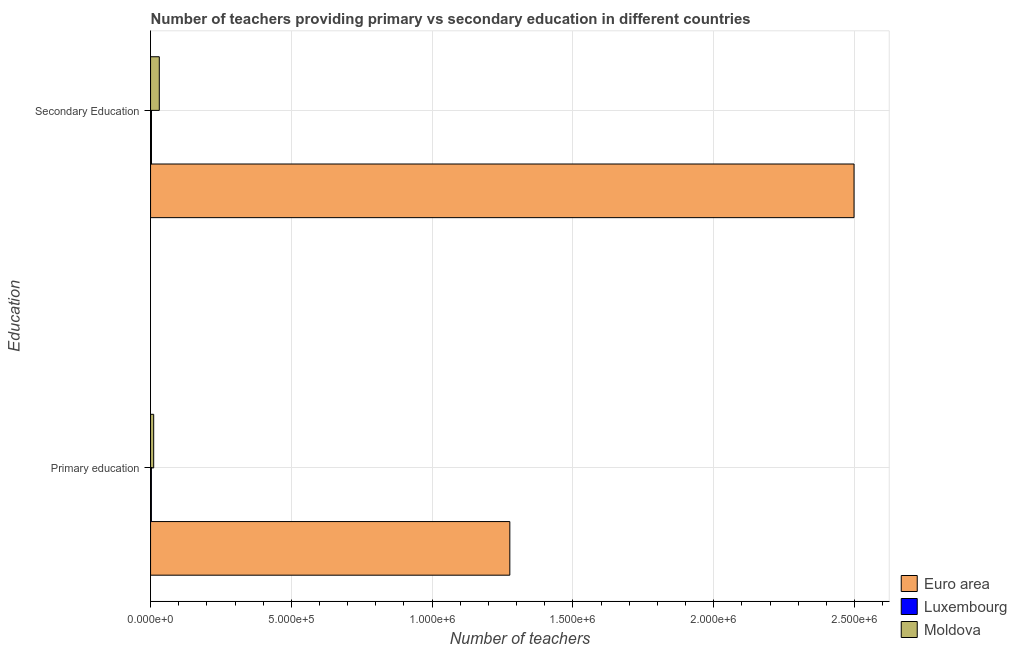How many different coloured bars are there?
Your answer should be compact. 3. How many groups of bars are there?
Provide a short and direct response. 2. Are the number of bars on each tick of the Y-axis equal?
Make the answer very short. Yes. How many bars are there on the 2nd tick from the top?
Ensure brevity in your answer.  3. How many bars are there on the 1st tick from the bottom?
Keep it short and to the point. 3. What is the label of the 1st group of bars from the top?
Give a very brief answer. Secondary Education. What is the number of secondary teachers in Moldova?
Provide a short and direct response. 3.10e+04. Across all countries, what is the maximum number of secondary teachers?
Provide a short and direct response. 2.50e+06. Across all countries, what is the minimum number of primary teachers?
Give a very brief answer. 2966. In which country was the number of secondary teachers minimum?
Ensure brevity in your answer.  Luxembourg. What is the total number of secondary teachers in the graph?
Offer a terse response. 2.53e+06. What is the difference between the number of secondary teachers in Moldova and that in Luxembourg?
Ensure brevity in your answer.  2.77e+04. What is the difference between the number of secondary teachers in Luxembourg and the number of primary teachers in Euro area?
Offer a terse response. -1.27e+06. What is the average number of primary teachers per country?
Your response must be concise. 4.30e+05. What is the difference between the number of primary teachers and number of secondary teachers in Moldova?
Provide a succinct answer. -1.99e+04. What is the ratio of the number of primary teachers in Moldova to that in Luxembourg?
Keep it short and to the point. 3.74. In how many countries, is the number of primary teachers greater than the average number of primary teachers taken over all countries?
Your response must be concise. 1. What does the 1st bar from the top in Primary education represents?
Offer a terse response. Moldova. What does the 3rd bar from the bottom in Secondary Education represents?
Your answer should be compact. Moldova. How many bars are there?
Your response must be concise. 6. What is the difference between two consecutive major ticks on the X-axis?
Provide a succinct answer. 5.00e+05. Does the graph contain any zero values?
Your response must be concise. No. Where does the legend appear in the graph?
Offer a terse response. Bottom right. What is the title of the graph?
Your response must be concise. Number of teachers providing primary vs secondary education in different countries. Does "Mali" appear as one of the legend labels in the graph?
Provide a short and direct response. No. What is the label or title of the X-axis?
Give a very brief answer. Number of teachers. What is the label or title of the Y-axis?
Ensure brevity in your answer.  Education. What is the Number of teachers in Euro area in Primary education?
Provide a succinct answer. 1.28e+06. What is the Number of teachers of Luxembourg in Primary education?
Offer a very short reply. 2966. What is the Number of teachers in Moldova in Primary education?
Provide a succinct answer. 1.11e+04. What is the Number of teachers in Euro area in Secondary Education?
Offer a very short reply. 2.50e+06. What is the Number of teachers in Luxembourg in Secondary Education?
Your response must be concise. 3279. What is the Number of teachers of Moldova in Secondary Education?
Provide a succinct answer. 3.10e+04. Across all Education, what is the maximum Number of teachers of Euro area?
Offer a terse response. 2.50e+06. Across all Education, what is the maximum Number of teachers in Luxembourg?
Ensure brevity in your answer.  3279. Across all Education, what is the maximum Number of teachers in Moldova?
Your answer should be very brief. 3.10e+04. Across all Education, what is the minimum Number of teachers of Euro area?
Give a very brief answer. 1.28e+06. Across all Education, what is the minimum Number of teachers in Luxembourg?
Provide a succinct answer. 2966. Across all Education, what is the minimum Number of teachers of Moldova?
Offer a terse response. 1.11e+04. What is the total Number of teachers in Euro area in the graph?
Your answer should be very brief. 3.77e+06. What is the total Number of teachers in Luxembourg in the graph?
Your answer should be very brief. 6245. What is the total Number of teachers of Moldova in the graph?
Your answer should be very brief. 4.21e+04. What is the difference between the Number of teachers in Euro area in Primary education and that in Secondary Education?
Your answer should be very brief. -1.22e+06. What is the difference between the Number of teachers of Luxembourg in Primary education and that in Secondary Education?
Provide a succinct answer. -313. What is the difference between the Number of teachers in Moldova in Primary education and that in Secondary Education?
Offer a terse response. -1.99e+04. What is the difference between the Number of teachers of Euro area in Primary education and the Number of teachers of Luxembourg in Secondary Education?
Your answer should be very brief. 1.27e+06. What is the difference between the Number of teachers of Euro area in Primary education and the Number of teachers of Moldova in Secondary Education?
Offer a very short reply. 1.24e+06. What is the difference between the Number of teachers of Luxembourg in Primary education and the Number of teachers of Moldova in Secondary Education?
Ensure brevity in your answer.  -2.80e+04. What is the average Number of teachers in Euro area per Education?
Provide a short and direct response. 1.89e+06. What is the average Number of teachers in Luxembourg per Education?
Provide a succinct answer. 3122.5. What is the average Number of teachers in Moldova per Education?
Keep it short and to the point. 2.10e+04. What is the difference between the Number of teachers of Euro area and Number of teachers of Luxembourg in Primary education?
Provide a short and direct response. 1.27e+06. What is the difference between the Number of teachers of Euro area and Number of teachers of Moldova in Primary education?
Provide a short and direct response. 1.26e+06. What is the difference between the Number of teachers in Luxembourg and Number of teachers in Moldova in Primary education?
Your answer should be very brief. -8121. What is the difference between the Number of teachers of Euro area and Number of teachers of Luxembourg in Secondary Education?
Your response must be concise. 2.50e+06. What is the difference between the Number of teachers of Euro area and Number of teachers of Moldova in Secondary Education?
Your answer should be compact. 2.47e+06. What is the difference between the Number of teachers of Luxembourg and Number of teachers of Moldova in Secondary Education?
Your response must be concise. -2.77e+04. What is the ratio of the Number of teachers in Euro area in Primary education to that in Secondary Education?
Provide a short and direct response. 0.51. What is the ratio of the Number of teachers of Luxembourg in Primary education to that in Secondary Education?
Offer a very short reply. 0.9. What is the ratio of the Number of teachers of Moldova in Primary education to that in Secondary Education?
Offer a terse response. 0.36. What is the difference between the highest and the second highest Number of teachers of Euro area?
Your answer should be very brief. 1.22e+06. What is the difference between the highest and the second highest Number of teachers in Luxembourg?
Offer a very short reply. 313. What is the difference between the highest and the second highest Number of teachers in Moldova?
Provide a short and direct response. 1.99e+04. What is the difference between the highest and the lowest Number of teachers of Euro area?
Your answer should be very brief. 1.22e+06. What is the difference between the highest and the lowest Number of teachers of Luxembourg?
Make the answer very short. 313. What is the difference between the highest and the lowest Number of teachers of Moldova?
Provide a short and direct response. 1.99e+04. 